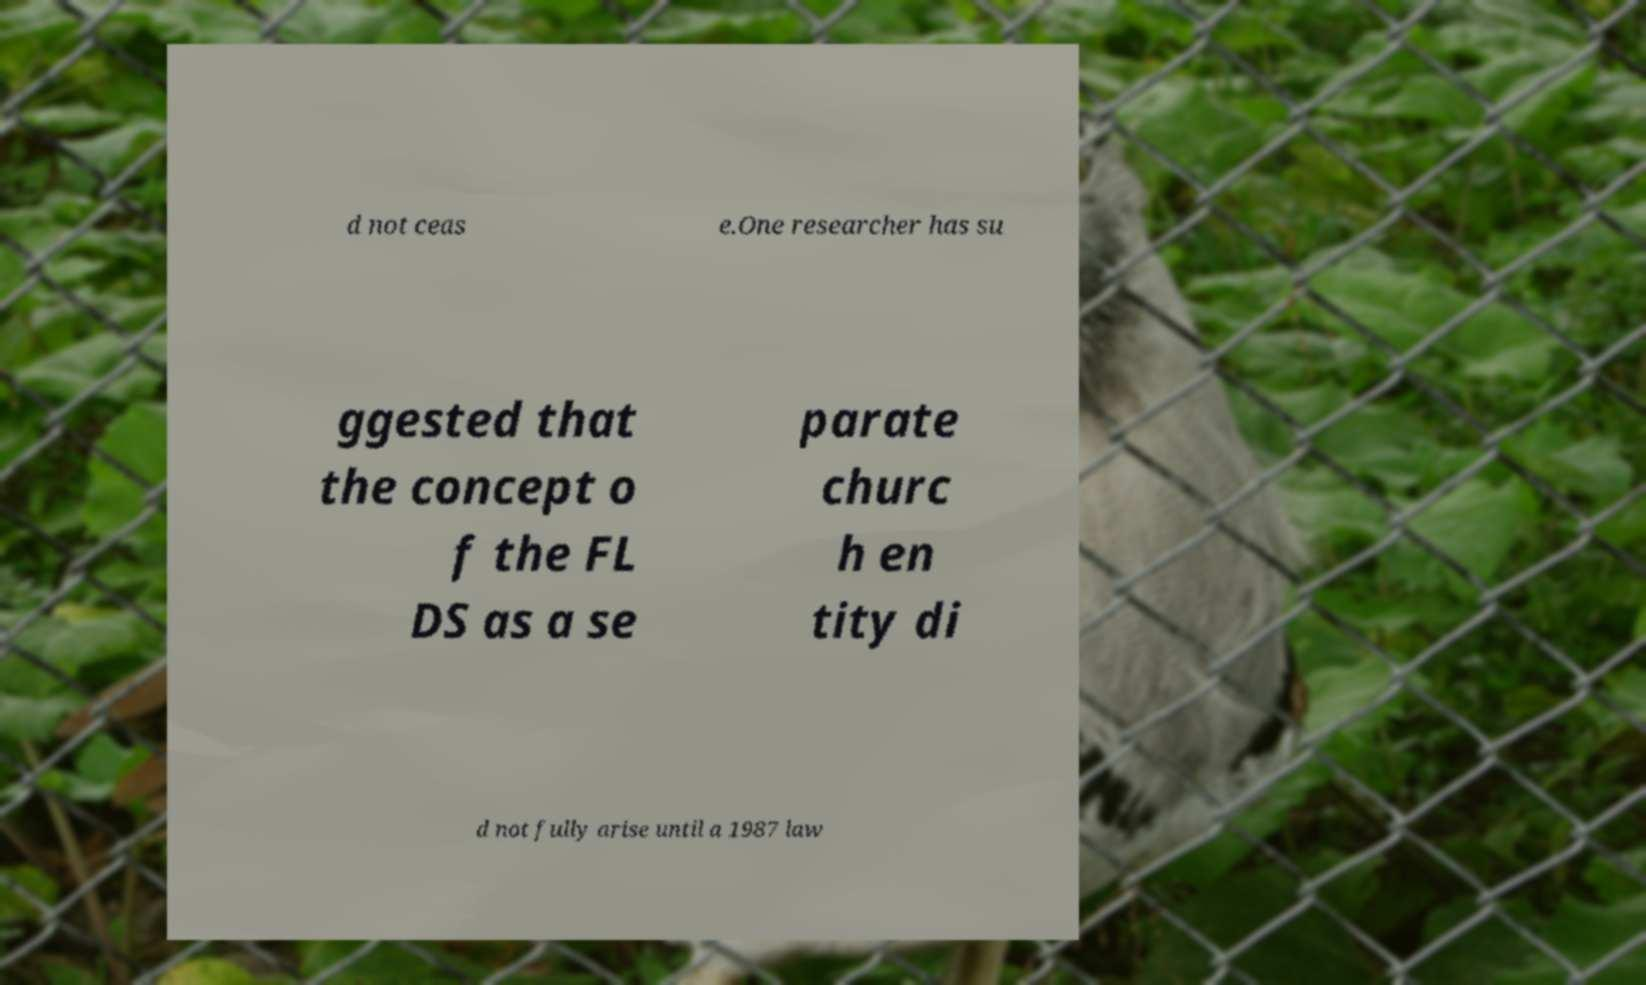For documentation purposes, I need the text within this image transcribed. Could you provide that? d not ceas e.One researcher has su ggested that the concept o f the FL DS as a se parate churc h en tity di d not fully arise until a 1987 law 